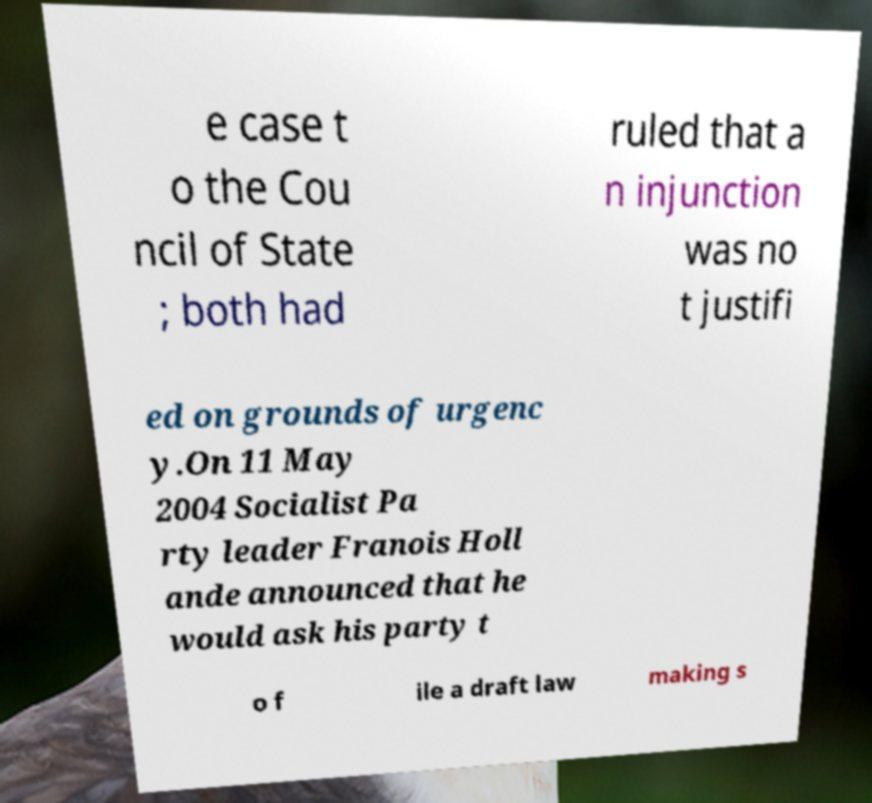Can you accurately transcribe the text from the provided image for me? e case t o the Cou ncil of State ; both had ruled that a n injunction was no t justifi ed on grounds of urgenc y.On 11 May 2004 Socialist Pa rty leader Franois Holl ande announced that he would ask his party t o f ile a draft law making s 